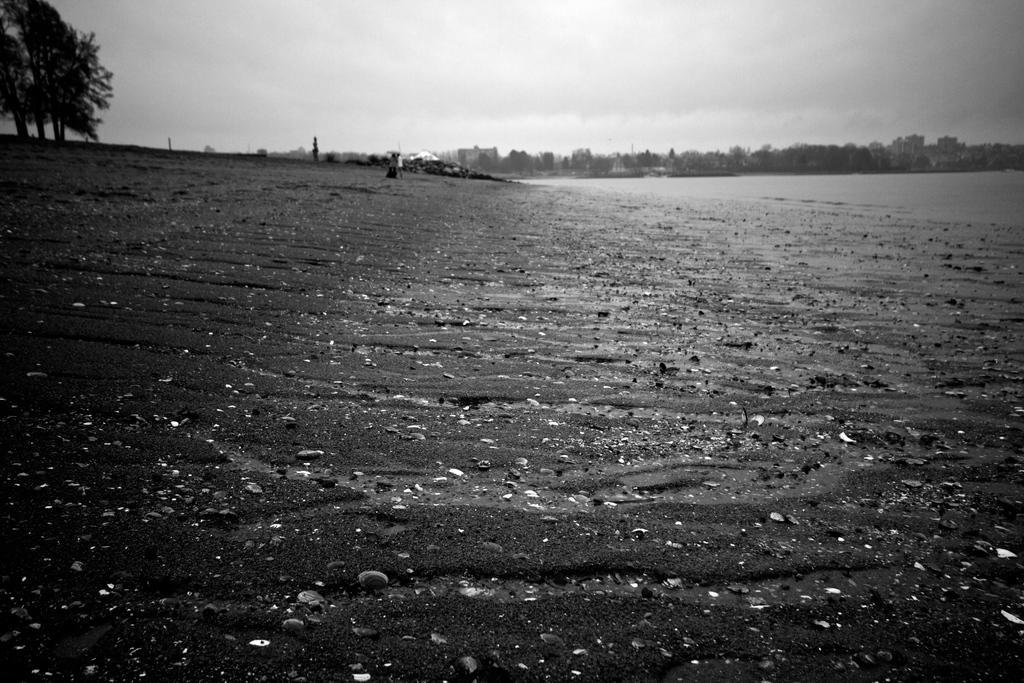Can you describe this image briefly? This is a black and white picture. Here we can see trees and buildings. In the background there is sky. 